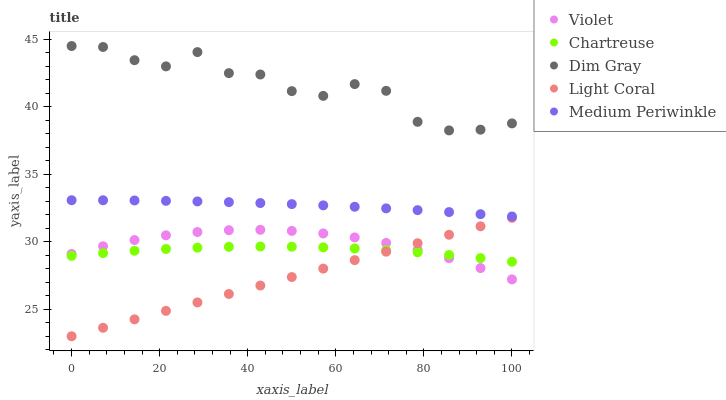Does Light Coral have the minimum area under the curve?
Answer yes or no. Yes. Does Dim Gray have the maximum area under the curve?
Answer yes or no. Yes. Does Chartreuse have the minimum area under the curve?
Answer yes or no. No. Does Chartreuse have the maximum area under the curve?
Answer yes or no. No. Is Light Coral the smoothest?
Answer yes or no. Yes. Is Dim Gray the roughest?
Answer yes or no. Yes. Is Chartreuse the smoothest?
Answer yes or no. No. Is Chartreuse the roughest?
Answer yes or no. No. Does Light Coral have the lowest value?
Answer yes or no. Yes. Does Chartreuse have the lowest value?
Answer yes or no. No. Does Dim Gray have the highest value?
Answer yes or no. Yes. Does Chartreuse have the highest value?
Answer yes or no. No. Is Violet less than Dim Gray?
Answer yes or no. Yes. Is Dim Gray greater than Light Coral?
Answer yes or no. Yes. Does Violet intersect Light Coral?
Answer yes or no. Yes. Is Violet less than Light Coral?
Answer yes or no. No. Is Violet greater than Light Coral?
Answer yes or no. No. Does Violet intersect Dim Gray?
Answer yes or no. No. 